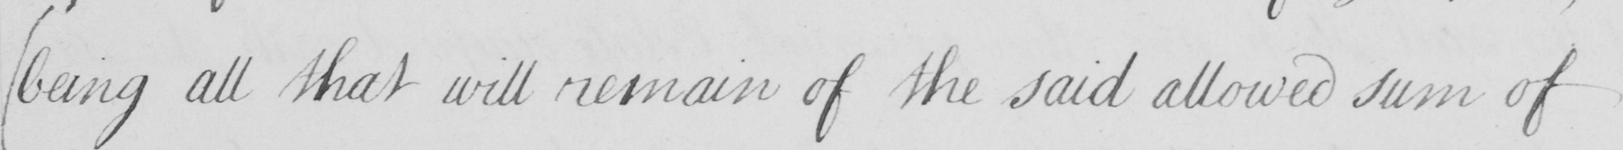What does this handwritten line say? ( being all that will remain of the said allowed sum of 